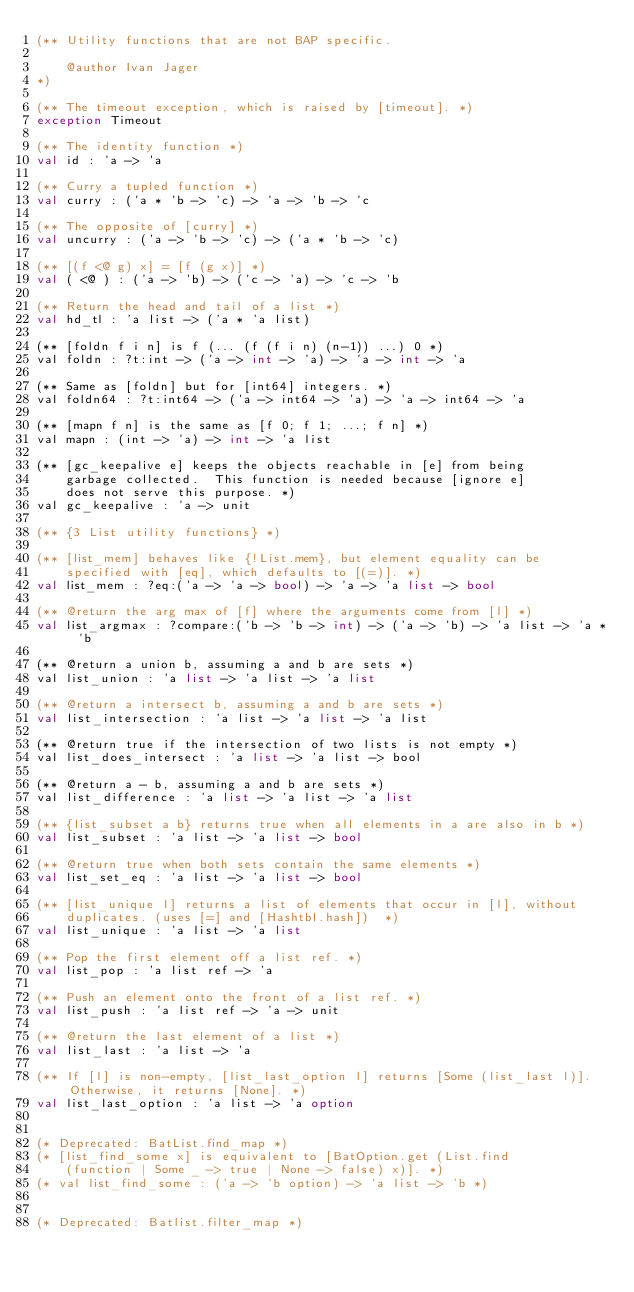<code> <loc_0><loc_0><loc_500><loc_500><_OCaml_>(** Utility functions that are not BAP specific.

    @author Ivan Jager
*)

(** The timeout exception, which is raised by [timeout]. *)
exception Timeout

(** The identity function *)
val id : 'a -> 'a

(** Curry a tupled function *)
val curry : ('a * 'b -> 'c) -> 'a -> 'b -> 'c

(** The opposite of [curry] *)
val uncurry : ('a -> 'b -> 'c) -> ('a * 'b -> 'c)

(** [(f <@ g) x] = [f (g x)] *)
val ( <@ ) : ('a -> 'b) -> ('c -> 'a) -> 'c -> 'b

(** Return the head and tail of a list *)
val hd_tl : 'a list -> ('a * 'a list)

(** [foldn f i n] is f (... (f (f i n) (n-1)) ...) 0 *)
val foldn : ?t:int -> ('a -> int -> 'a) -> 'a -> int -> 'a

(** Same as [foldn] but for [int64] integers. *)
val foldn64 : ?t:int64 -> ('a -> int64 -> 'a) -> 'a -> int64 -> 'a

(** [mapn f n] is the same as [f 0; f 1; ...; f n] *)
val mapn : (int -> 'a) -> int -> 'a list

(** [gc_keepalive e] keeps the objects reachable in [e] from being
    garbage collected.  This function is needed because [ignore e]
    does not serve this purpose. *)
val gc_keepalive : 'a -> unit

(** {3 List utility functions} *)

(** [list_mem] behaves like {!List.mem}, but element equality can be
    specified with [eq], which defaults to [(=)]. *)
val list_mem : ?eq:('a -> 'a -> bool) -> 'a -> 'a list -> bool

(** @return the arg max of [f] where the arguments come from [l] *)
val list_argmax : ?compare:('b -> 'b -> int) -> ('a -> 'b) -> 'a list -> 'a * 'b

(** @return a union b, assuming a and b are sets *)
val list_union : 'a list -> 'a list -> 'a list

(** @return a intersect b, assuming a and b are sets *)
val list_intersection : 'a list -> 'a list -> 'a list

(** @return true if the intersection of two lists is not empty *)
val list_does_intersect : 'a list -> 'a list -> bool

(** @return a - b, assuming a and b are sets *)
val list_difference : 'a list -> 'a list -> 'a list

(** {list_subset a b} returns true when all elements in a are also in b *)
val list_subset : 'a list -> 'a list -> bool

(** @return true when both sets contain the same elements *)
val list_set_eq : 'a list -> 'a list -> bool

(** [list_unique l] returns a list of elements that occur in [l], without
    duplicates. (uses [=] and [Hashtbl.hash])  *)
val list_unique : 'a list -> 'a list

(** Pop the first element off a list ref. *)
val list_pop : 'a list ref -> 'a

(** Push an element onto the front of a list ref. *)
val list_push : 'a list ref -> 'a -> unit

(** @return the last element of a list *)
val list_last : 'a list -> 'a

(** If [l] is non-empty, [list_last_option l] returns [Some (list_last l)].  Otherwise, it returns [None]. *)
val list_last_option : 'a list -> 'a option


(* Deprecated: BatList.find_map *)
(* [list_find_some x] is equivalent to [BatOption.get (List.find
    (function | Some _ -> true | None -> false) x)]. *)
(* val list_find_some : ('a -> 'b option) -> 'a list -> 'b *)


(* Deprecated: Batlist.filter_map *)</code> 